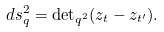<formula> <loc_0><loc_0><loc_500><loc_500>d s ^ { 2 } _ { q } = { \det } _ { q ^ { 2 } } ( z _ { t } - z _ { t ^ { \prime } } ) .</formula> 